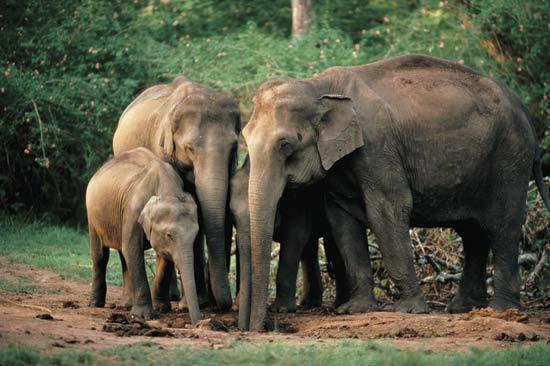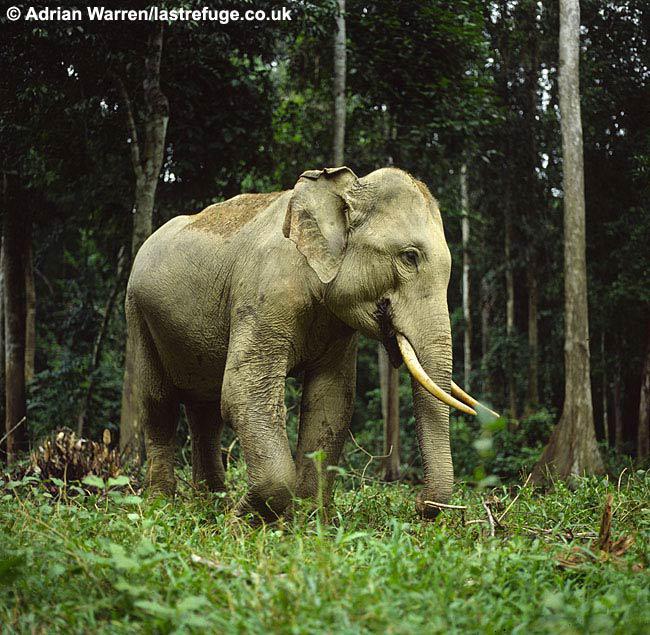The first image is the image on the left, the second image is the image on the right. Evaluate the accuracy of this statement regarding the images: "The elephant in the image on the right has its feet on a man made structure.". Is it true? Answer yes or no. No. The first image is the image on the left, the second image is the image on the right. For the images shown, is this caption "Both elephants are facing towards the left." true? Answer yes or no. No. 